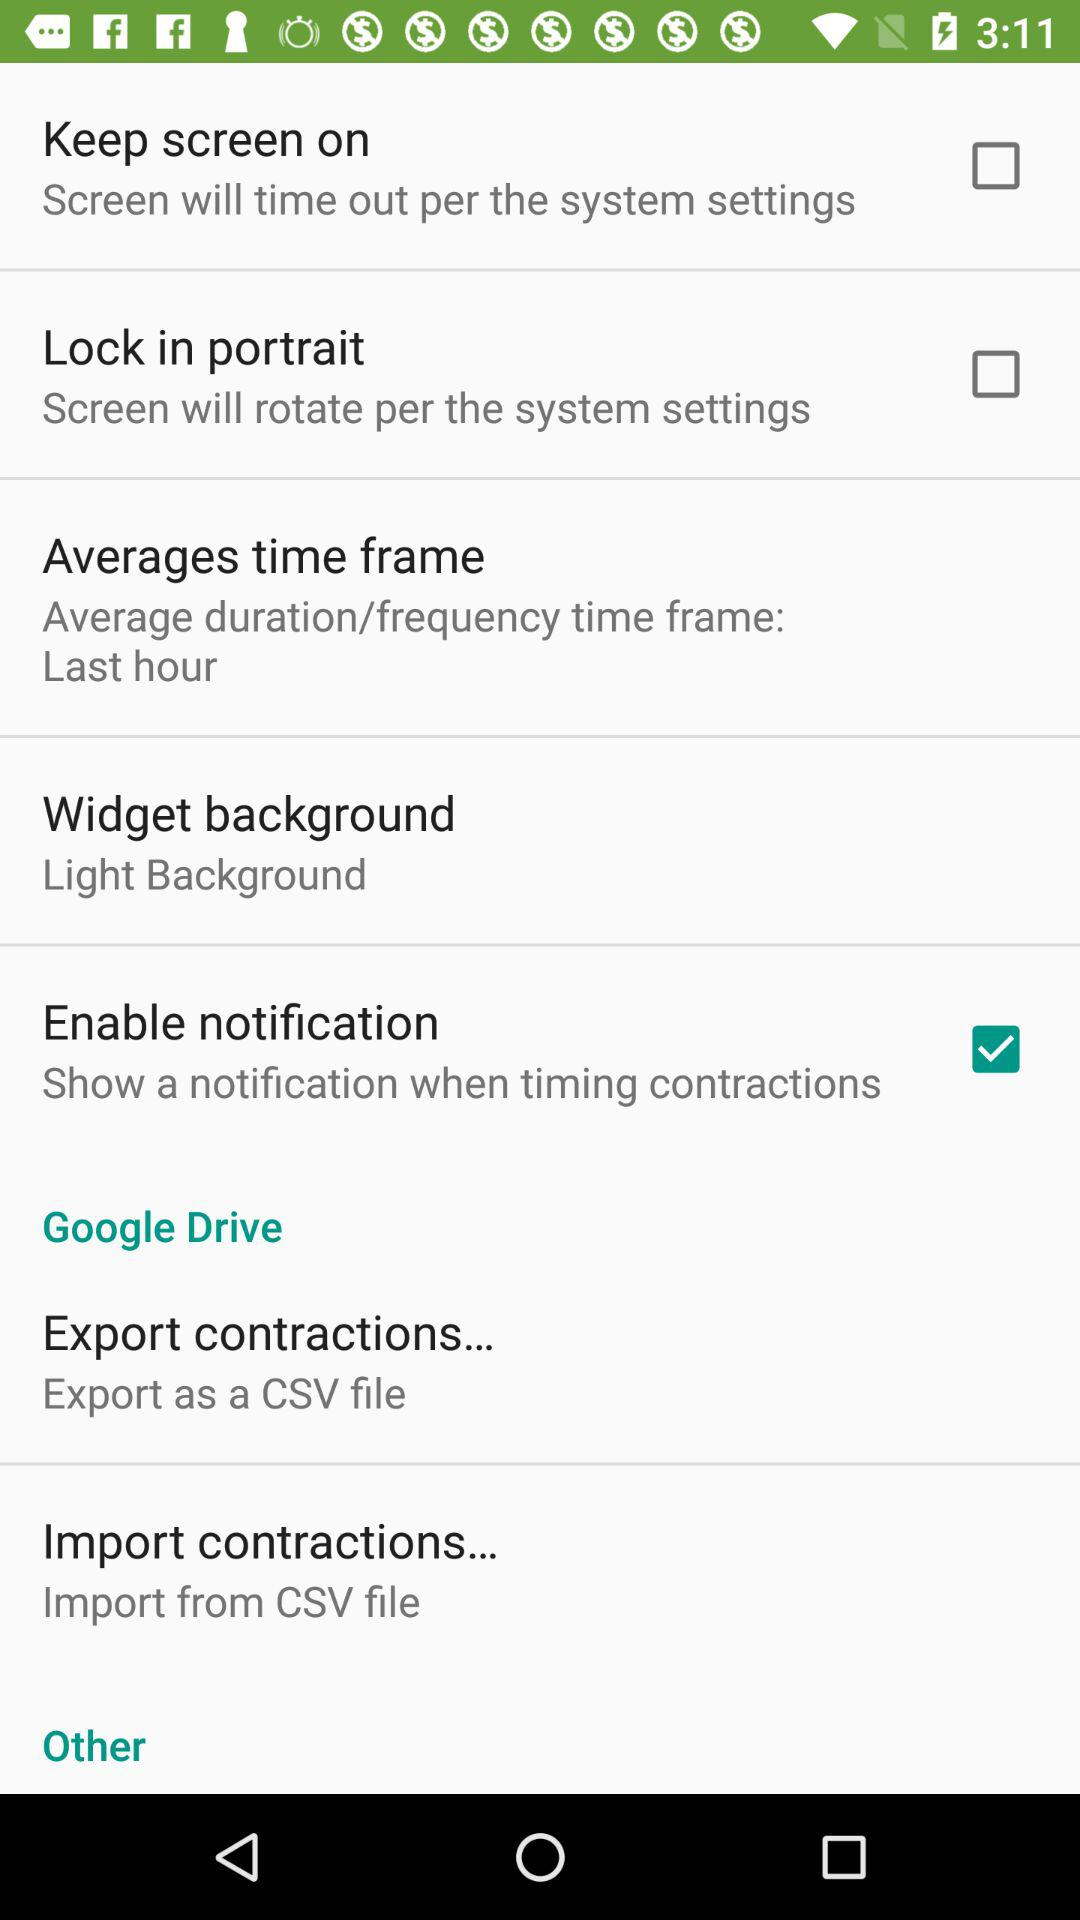From which file can the contractions be imported? The contractions can be imported from a CSV file. 